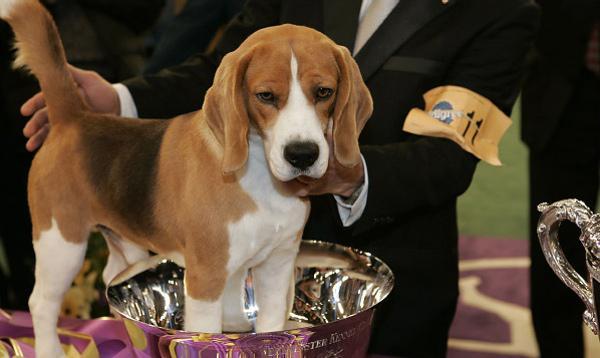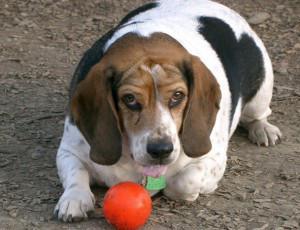The first image is the image on the left, the second image is the image on the right. For the images shown, is this caption "An image shows at least one beagle dog eating from a bowl." true? Answer yes or no. No. The first image is the image on the left, the second image is the image on the right. Assess this claim about the two images: "At least one beagle is eating out of a bowl.". Correct or not? Answer yes or no. No. 